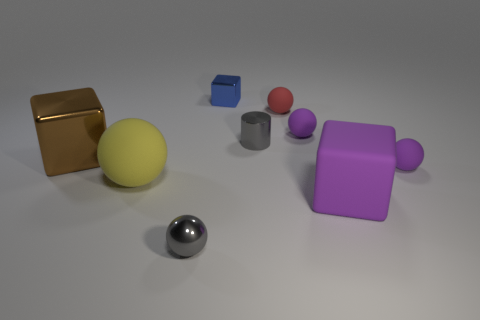Is there a large object of the same color as the big rubber sphere?
Ensure brevity in your answer.  No. Are any tiny cyan spheres visible?
Provide a short and direct response. No. Do the small red matte object and the yellow thing have the same shape?
Offer a very short reply. Yes. What number of tiny things are brown rubber spheres or red matte balls?
Make the answer very short. 1. What is the color of the rubber block?
Provide a succinct answer. Purple. What shape is the thing on the left side of the matte ball left of the gray ball?
Offer a very short reply. Cube. Is there a blue thing that has the same material as the small gray cylinder?
Give a very brief answer. Yes. Does the object behind the red matte object have the same size as the gray ball?
Ensure brevity in your answer.  Yes. What number of purple objects are large rubber balls or tiny metal objects?
Offer a very short reply. 0. What is the material of the tiny sphere in front of the big matte sphere?
Your response must be concise. Metal. 